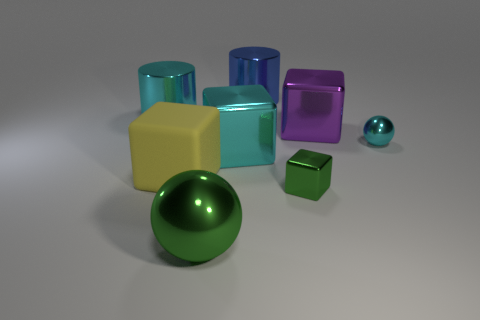Subtract all big rubber blocks. How many blocks are left? 3 Add 1 blue cylinders. How many objects exist? 9 Subtract all purple cubes. How many cubes are left? 3 Subtract all cylinders. How many objects are left? 6 Subtract 2 cubes. How many cubes are left? 2 Add 2 large purple balls. How many large purple balls exist? 2 Subtract 0 yellow spheres. How many objects are left? 8 Subtract all cyan balls. Subtract all purple cubes. How many balls are left? 1 Subtract all large gray rubber balls. Subtract all big cyan blocks. How many objects are left? 7 Add 6 purple blocks. How many purple blocks are left? 7 